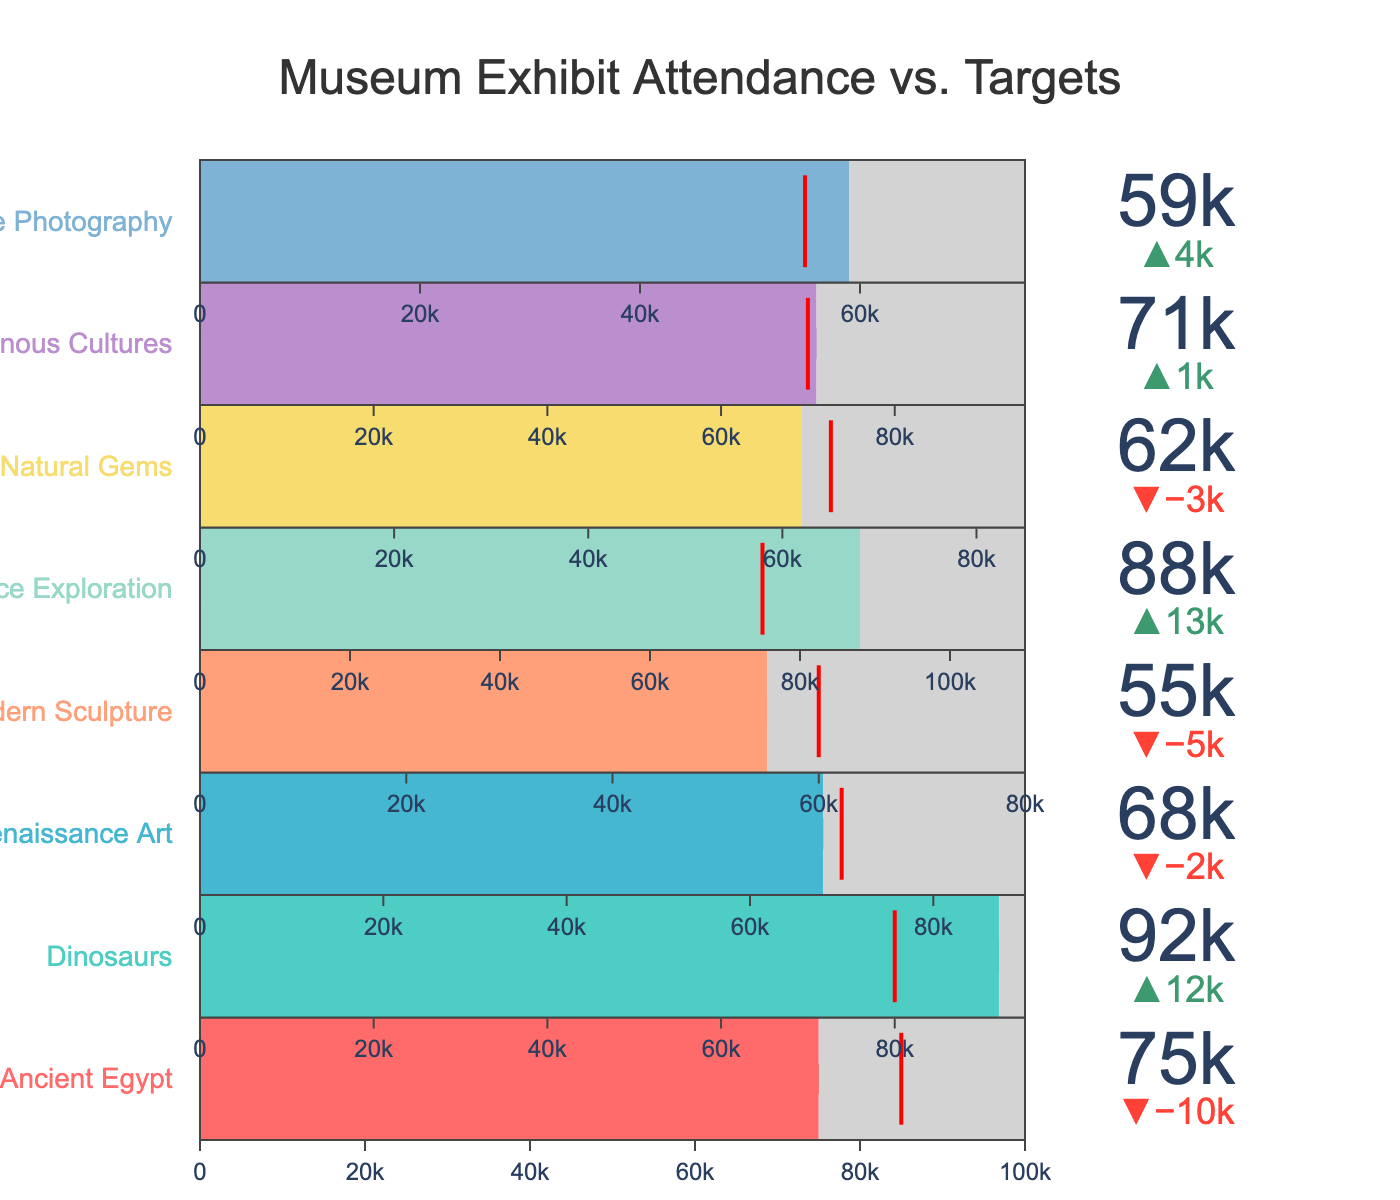What is the title of the chart? The title is displayed at the top of the chart and generally gives an overall description of what the chart represents. In this case, the title is located at the top center.
Answer: Museum Exhibit Attendance vs. Targets How many exhibits exceeded their target attendance? To determine this, look at each exhibit's actual attendance and compare it to its target attendance. Count the number of exhibits where the actual attendance exceeds the target.
Answer: 5 Which exhibit had the highest actual attendance? Compare the actual attendance figures for all exhibits. The highest value determines which exhibit had the most visitors.
Answer: Dinosaurs What is the difference between the actual and target attendance for the exhibit "Space Exploration"? Subtract the target attendance from the actual attendance: 88000 - 75000.
Answer: 13000 Which exhibits failed to meet their target attendance? Check each exhibit's actual attendance versus its target attendance. List the exhibits where actual attendance is less than the target.
Answer: Ancient Egypt, Renaissance Art, Modern Sculpture, Natural Gems What is the closest exhibit to reaching its maximum capacity based on actual attendance? Calculate the ratio of actual attendance to maximum capacity for each exhibit and find the one with the highest ratio.
Answer: Dinosaurs (92000/95000 = 0.968) Which exhibit had the smallest difference between actual and target attendance? Subtract the target attendance from the actual attendance for each exhibit, and find the smallest absolute difference.
Answer: Indigenous Cultures (71000 - 70000 = 1000) What is the total target attendance for all exhibits? Add up the target attendance values for all exhibits.
Answer: 560000 Which exhibit had the largest difference between actual attendance and its maximum capacity? For each exhibit, subtract actual attendance from the maximum capacity and find the largest difference.
Answer: Space Exploration (110000 - 88000 = 22000) How many exhibits had an actual attendance of 70000 or above? Count the number of exhibits where the actual attendance is 70000 or greater by comparing each exhibit's actual attendance value.
Answer: 5 